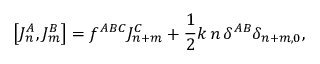Convert formula to latex. <formula><loc_0><loc_0><loc_500><loc_500>\left [ J _ { n } ^ { A } , J _ { m } ^ { B } \right ] = f ^ { A B C } J _ { n + m } ^ { C } + \frac { 1 } { 2 } k \, n \, \delta ^ { A B } \delta _ { n + m , 0 } ,</formula> 